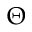Convert formula to latex. <formula><loc_0><loc_0><loc_500><loc_500>\Theta</formula> 